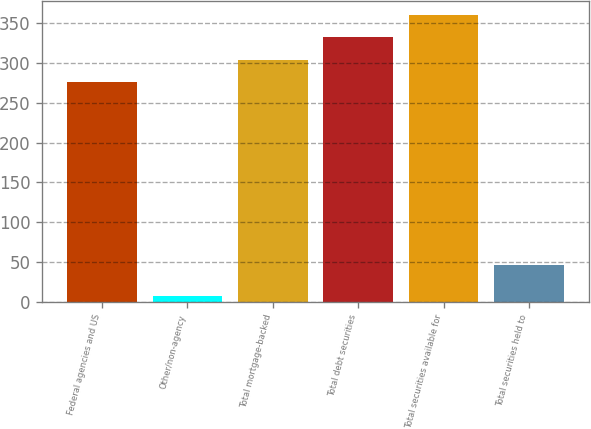Convert chart. <chart><loc_0><loc_0><loc_500><loc_500><bar_chart><fcel>Federal agencies and US<fcel>Other/non-agency<fcel>Total mortgage-backed<fcel>Total debt securities<fcel>Total securities available for<fcel>Total securities held to<nl><fcel>277<fcel>7<fcel>304.7<fcel>332.4<fcel>360.1<fcel>46<nl></chart> 